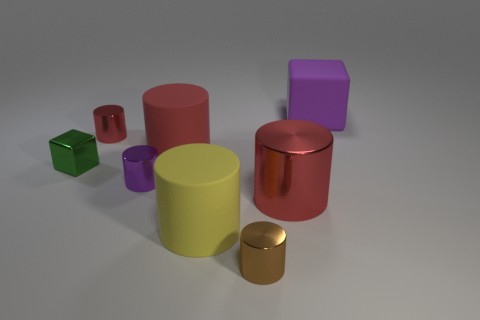How many objects are there, and could you classify them by color and shape? Absolutely. There are seven objects in total. In terms of color and shape, we have: a large red cylinder, a large yellow cylinder, a small green cube, a small gold cylinder, a medium-sized purple cube, a small violet cylinder, and a medium-sized red cube. Could these objects represent anything in particular, or are they just random shapes? The arrangement seems arbitrary without a specific context. However, the variety in shape and color could be used to discuss concepts related to geometry, material properties, or even to use as part of a creative composition in an art piece. 